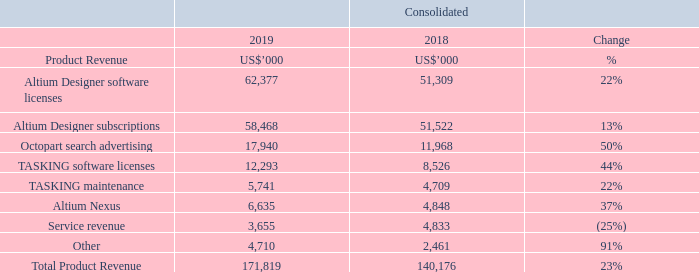Net Profit After Tax
Net profit after tax increased by 41.1% to US$52.9 million from US$37.5 million in the previous year.
The effective tax rate for the year was 8% (2018: 6%). This reflects the tax utilisation of the deferred tax asset recognised as a result of both temporary differences arising on relocation of Altium’s core business assets to the USA. Altium will continue to utilize the tax benefits and re-evaluate the valuation of the deferred tax asset on an annual basis.
For more details on revenue, refer to Note 3 of the annual report.
What are the years included in the table? 2019, 2018. What is the effective tax rate for 2019? 8%. What is the percentage change in the total product revenue from 2018 to 2019? 23%. Which year had a higher Total Product Revenue?   171,819 > 140,176 
Answer: 2019. What is the percentage of altium designer software licenses in total product revenue in 2018?
Answer scale should be: percent. 51,309/140,176
Answer: 36.6. What is the percentage of TASKING software licenses in total product revenue in 2018?
Answer scale should be: percent. 8,526/140,176
Answer: 6.08. 